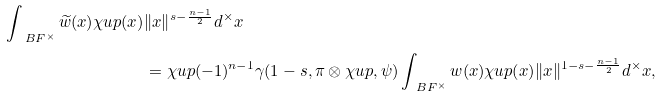Convert formula to latex. <formula><loc_0><loc_0><loc_500><loc_500>\int _ { \ B F ^ { \times } } \widetilde { w } ( x ) \chi u p ( x ) & \| x \| ^ { s - \frac { n - 1 } 2 } d ^ { \times } x \\ & = \chi u p ( - 1 ) ^ { n - 1 } \gamma ( 1 - s , \pi \otimes \chi u p , \psi ) \int _ { \ B F ^ { \times } } w ( x ) \chi u p ( x ) \| x \| ^ { 1 - s - \frac { n - 1 } 2 } d ^ { \times } x ,</formula> 